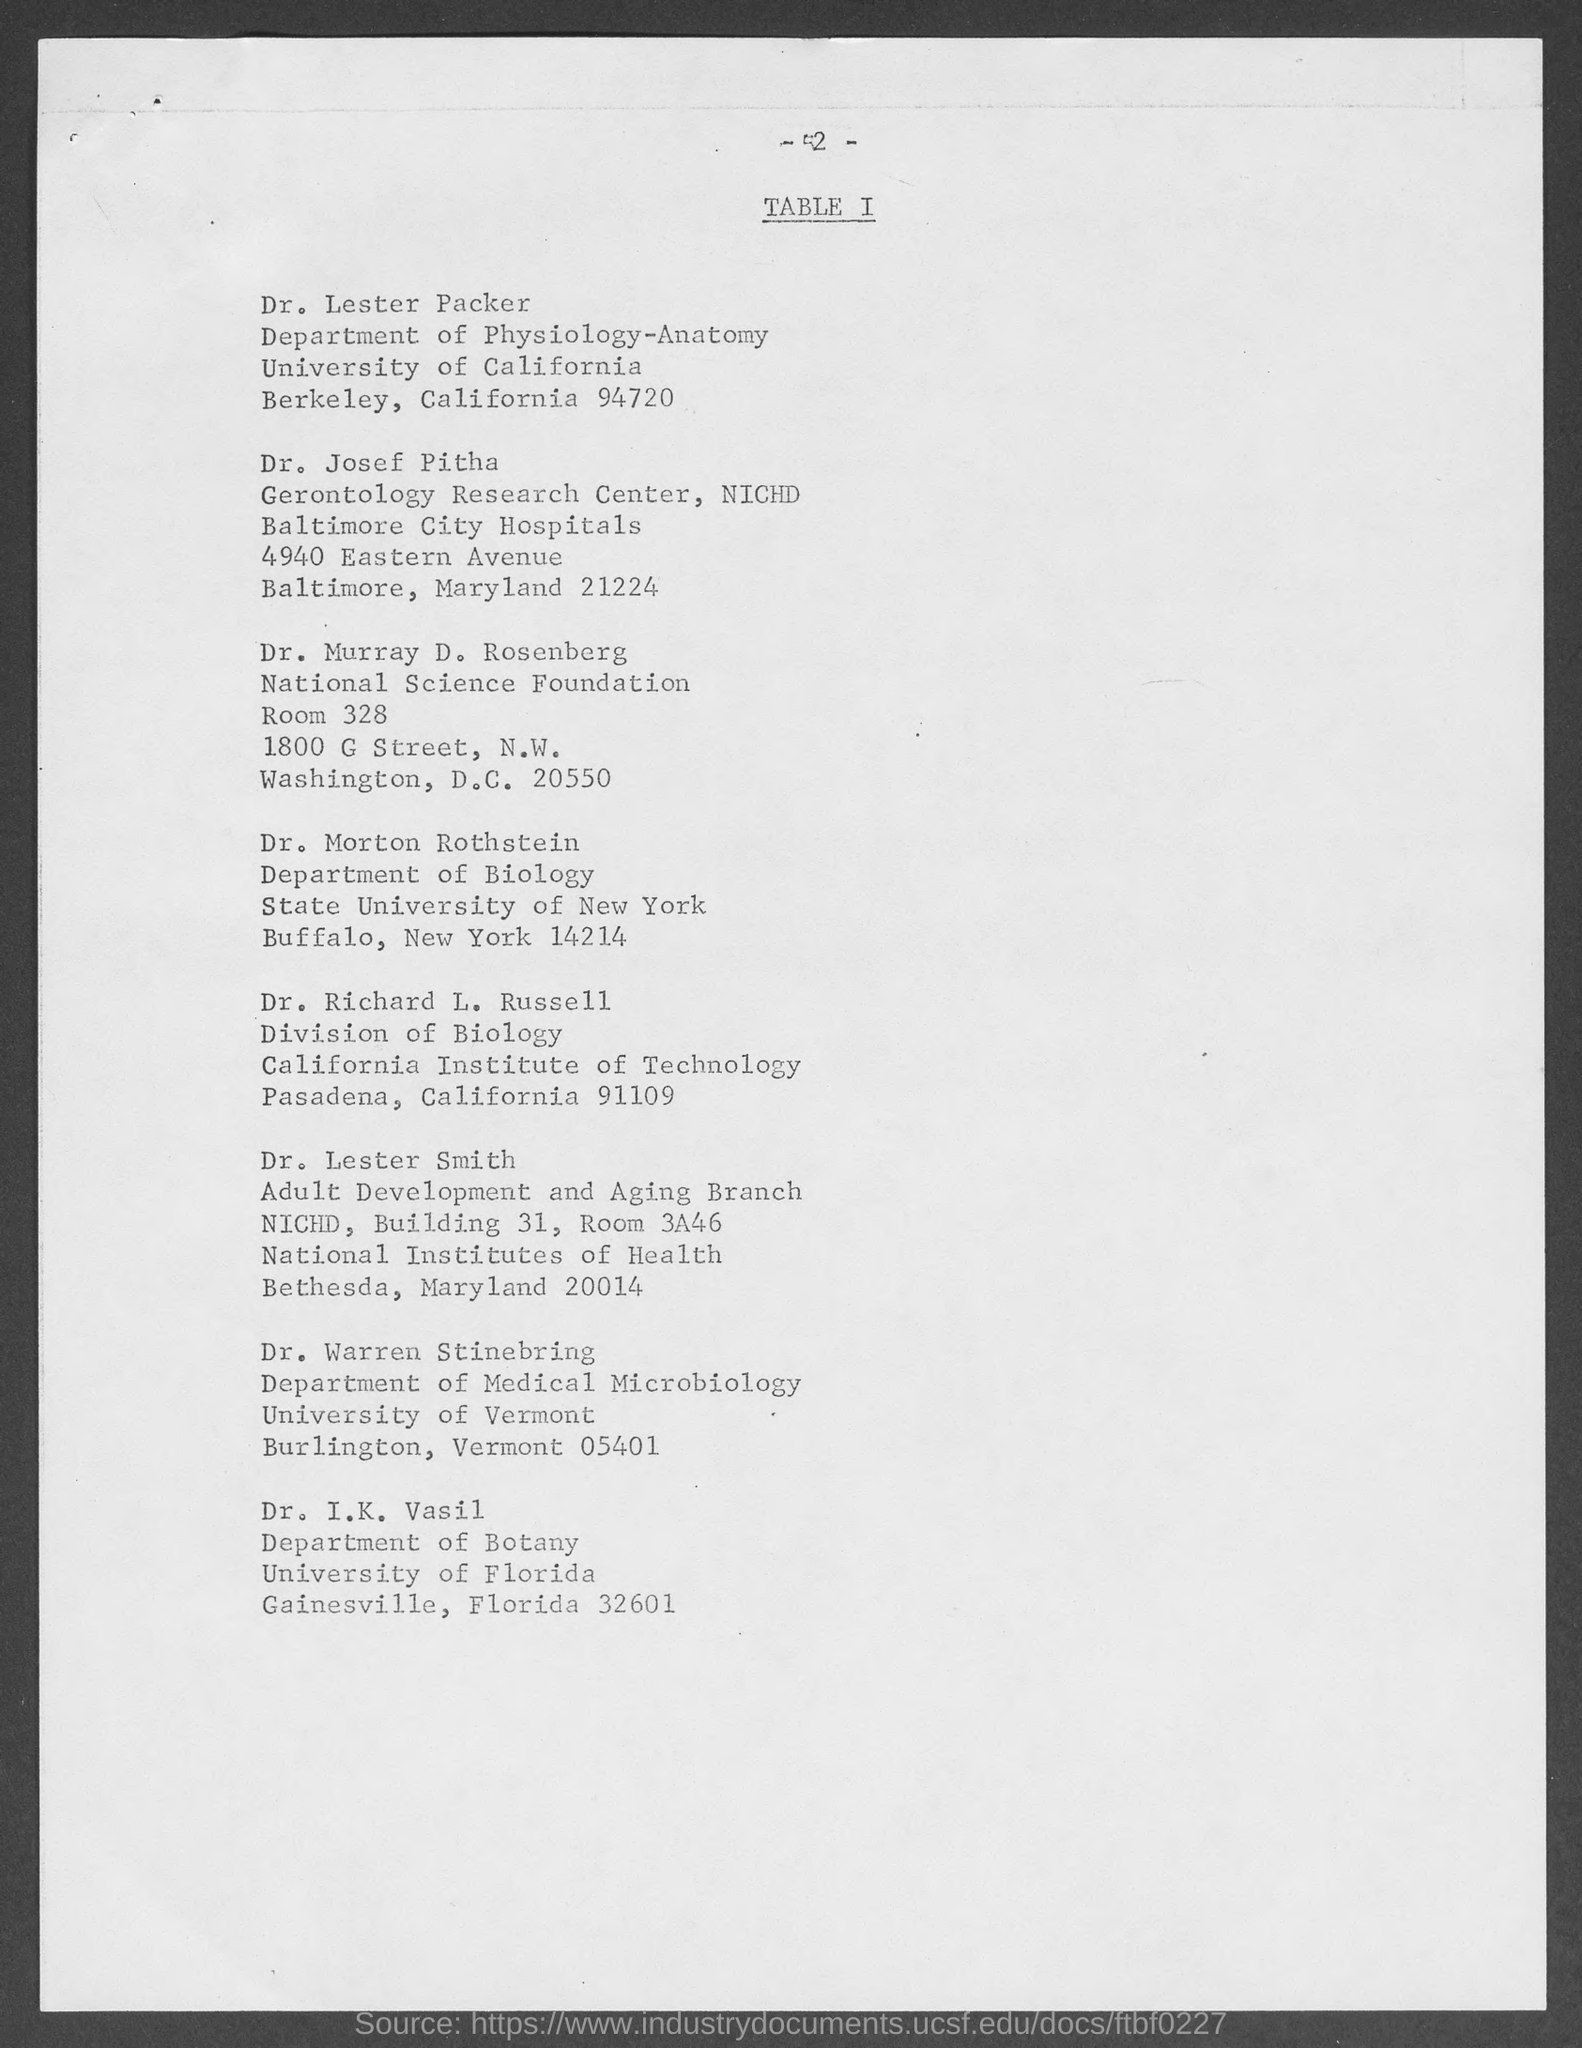Highlight a few significant elements in this photo. Dr. Lester Packer is a member of the University of California. Dr. Morton Rothstein belongs to the State University of New York. Dr. Richard L. Russell belongs to the California Institute of Technology. Dr. I. K. Vasil belongs to the University of Florida. The page number at the top of the page is two less than the number of years since the last presidential election. 